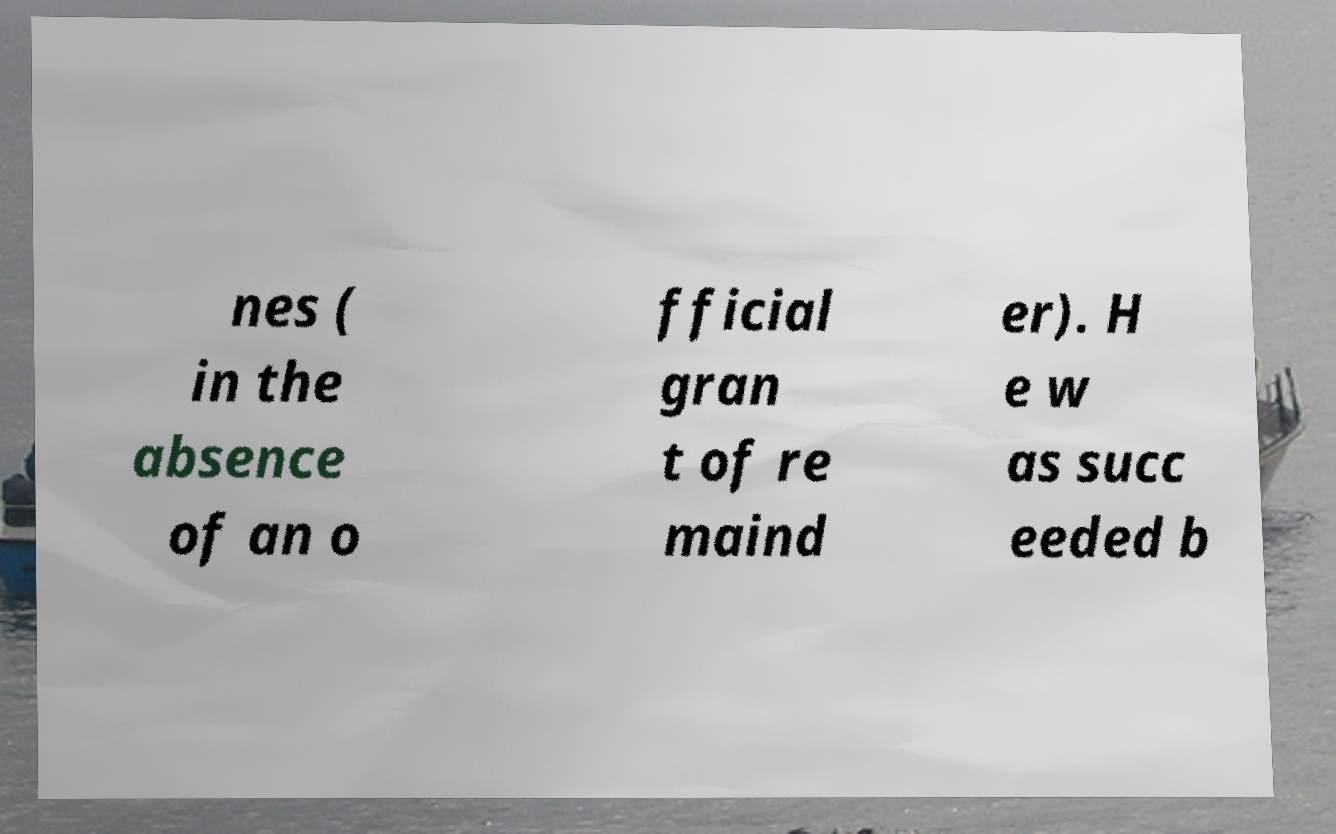I need the written content from this picture converted into text. Can you do that? nes ( in the absence of an o fficial gran t of re maind er). H e w as succ eeded b 